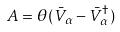<formula> <loc_0><loc_0><loc_500><loc_500>A = \theta ( \bar { V } _ { \alpha } - \bar { V } _ { \alpha } ^ { \dagger } )</formula> 